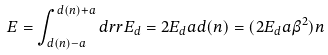Convert formula to latex. <formula><loc_0><loc_0><loc_500><loc_500>E = \int _ { d ( n ) - a } ^ { d ( n ) + a } d r r E _ { d } = 2 E _ { d } a d ( n ) = ( 2 E _ { d } a \beta ^ { 2 } ) n</formula> 